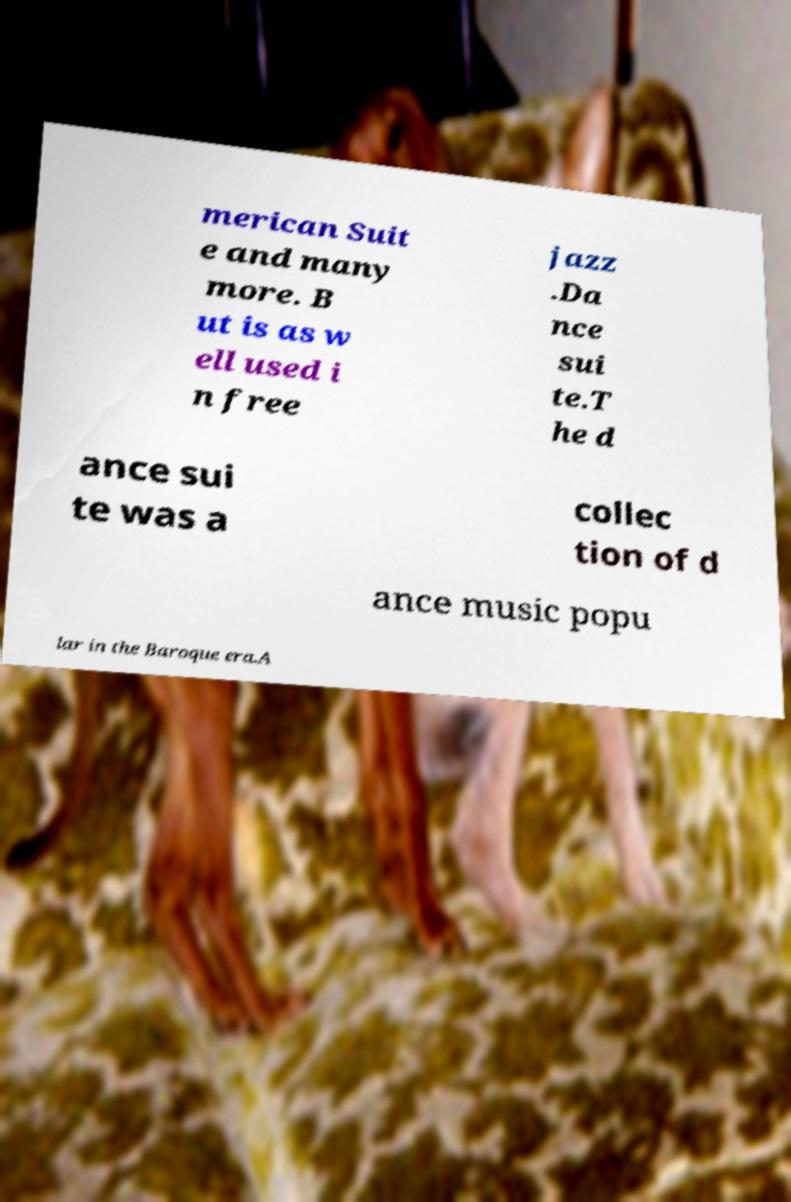Please identify and transcribe the text found in this image. merican Suit e and many more. B ut is as w ell used i n free jazz .Da nce sui te.T he d ance sui te was a collec tion of d ance music popu lar in the Baroque era.A 